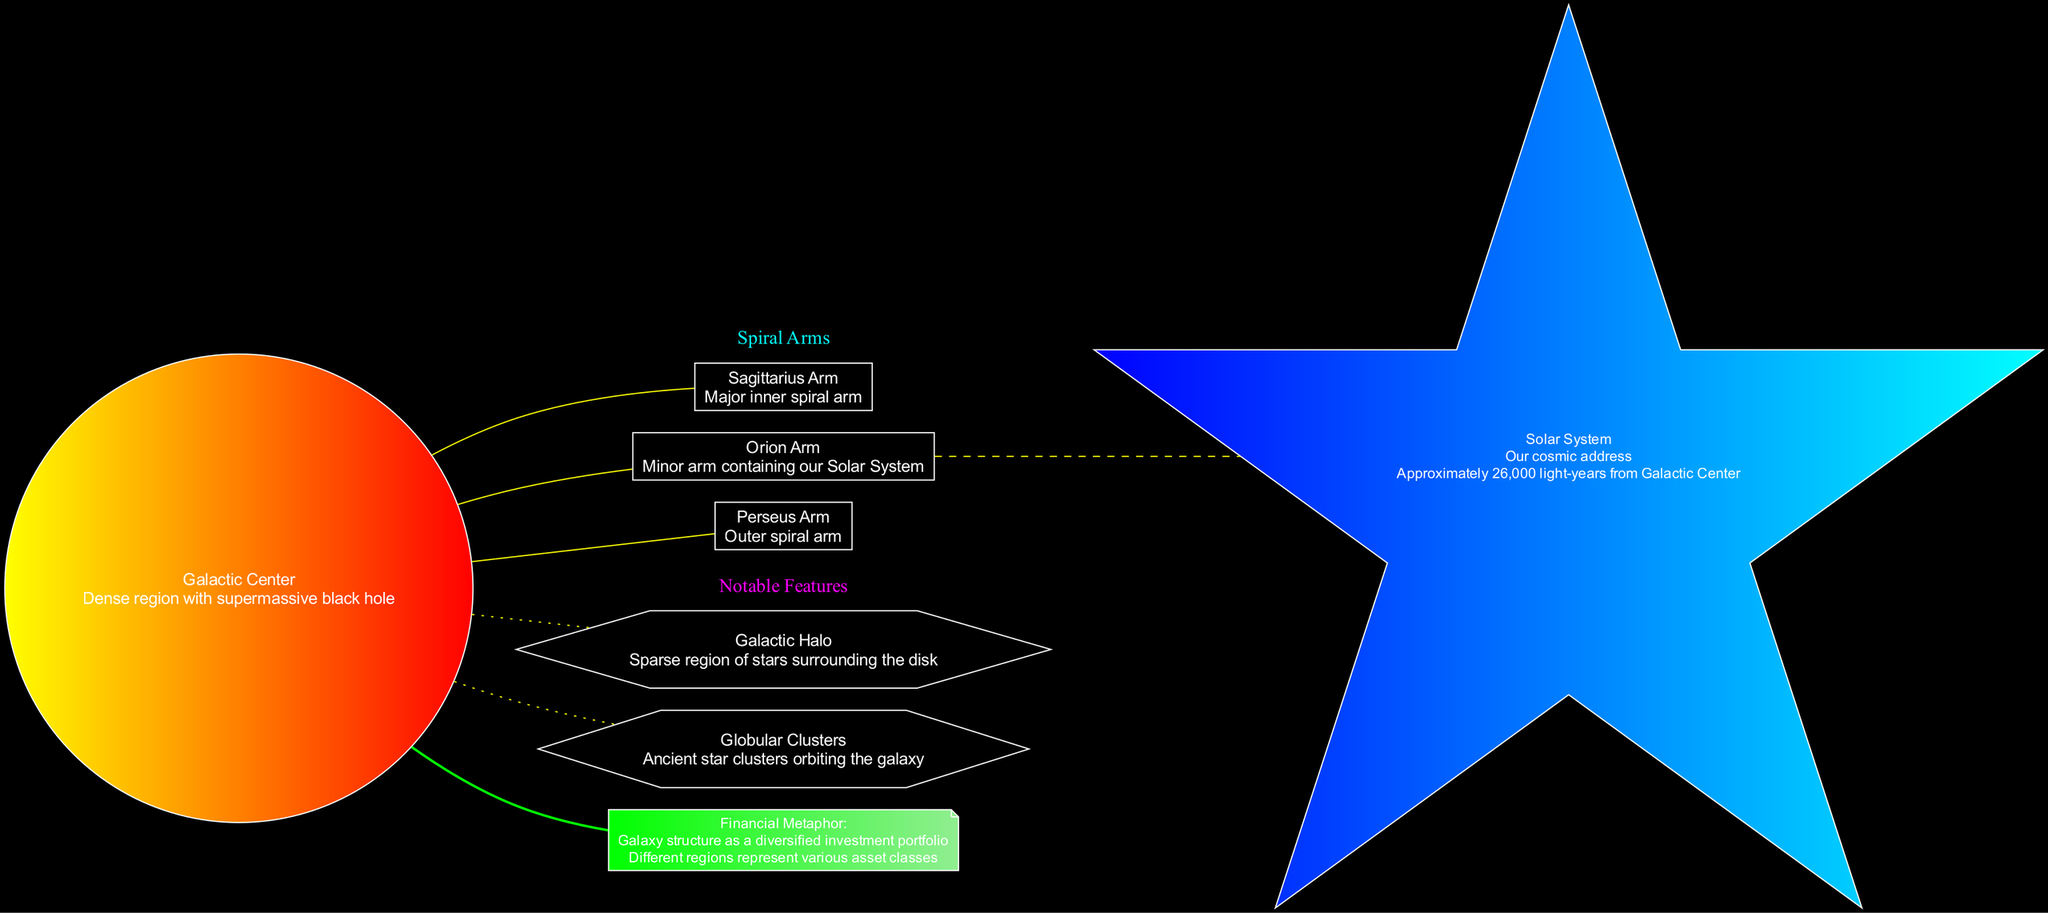What is the name of the inner spiral arm? The inner spiral arm is indicated in the diagram, and it is labeled as "Sagittarius Arm."
Answer: Sagittarius Arm How far is our Solar System from the Galactic Center? The diagram notes that the Solar System is located "Approximately 26,000 light-years from Galactic Center." This distance is explicitly mentioned in the description of the Solar System node.
Answer: Approximately 26,000 light-years How many spiral arms are shown in the diagram? The diagram lists three spiral arms: Perseus Arm, Orion Arm, and Sagittarius Arm. By counting these entries in the spiral arms section, we find the total is three.
Answer: 3 Which arm contains our Solar System? Examining the information in the diagram about the arms, the "Orion Arm" is specifically labeled as containing our Solar System. Therefore, it is the correct answer.
Answer: Orion Arm What feature is described as a "sparse region of stars surrounding the disk"? The diagram provides a description for the "Galactic Halo," which is identified as being sparse and surrounding the disk. This relationship is clearly stated in the notable features section.
Answer: Galactic Halo How does the diagram use the galaxy's structure as a metaphor? The diagram explains that the galaxy's structure can be viewed as a "diversified investment portfolio," where different regions of the galaxy represent various asset classes. This metaphor is labeled and described under financial metaphors.
Answer: Diversified investment portfolio What is the main function of the Galactic Center in the diagram? The Galactic Center is described as the "Dense region with supermassive black hole," indicating its significance. This function is directly stated in the center node.
Answer: Dense region with supermassive black hole What shape is used to represent the Solar System in the diagram? The Solar System is visually represented using a "star" shape in the diagram, as indicated by the shape designation in the node description.
Answer: Star Which feature is categorized under "Notable Features"? The diagram presents "Globular Clusters" and "Galactic Halo" as features under this category. Either can be an acceptable answer, but taking the first one explicitly mentioned can be a simpler choice.
Answer: Globular Clusters 